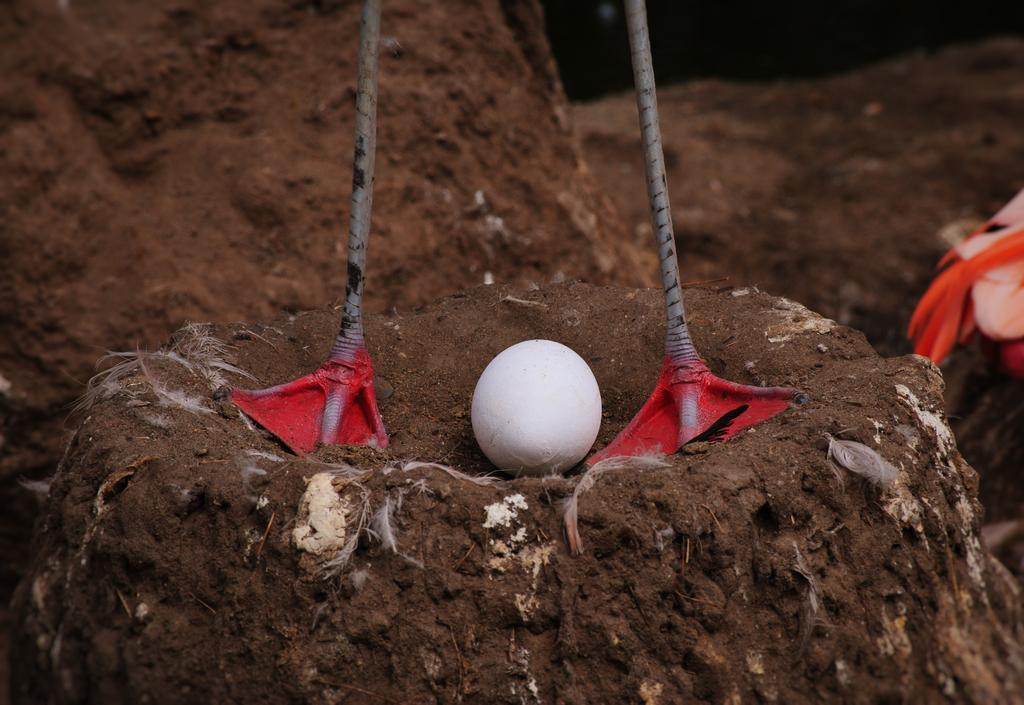What type of animal is represented by the legs in the image? The legs in the image belong to a bird. What can be seen near the legs in the image? There is an egg placed on the soil in the image. What type of government is depicted in the image? There is no government depicted in the image; it features the legs of a bird and an egg. How many zebras can be seen in the image? There are no zebras present in the image. 